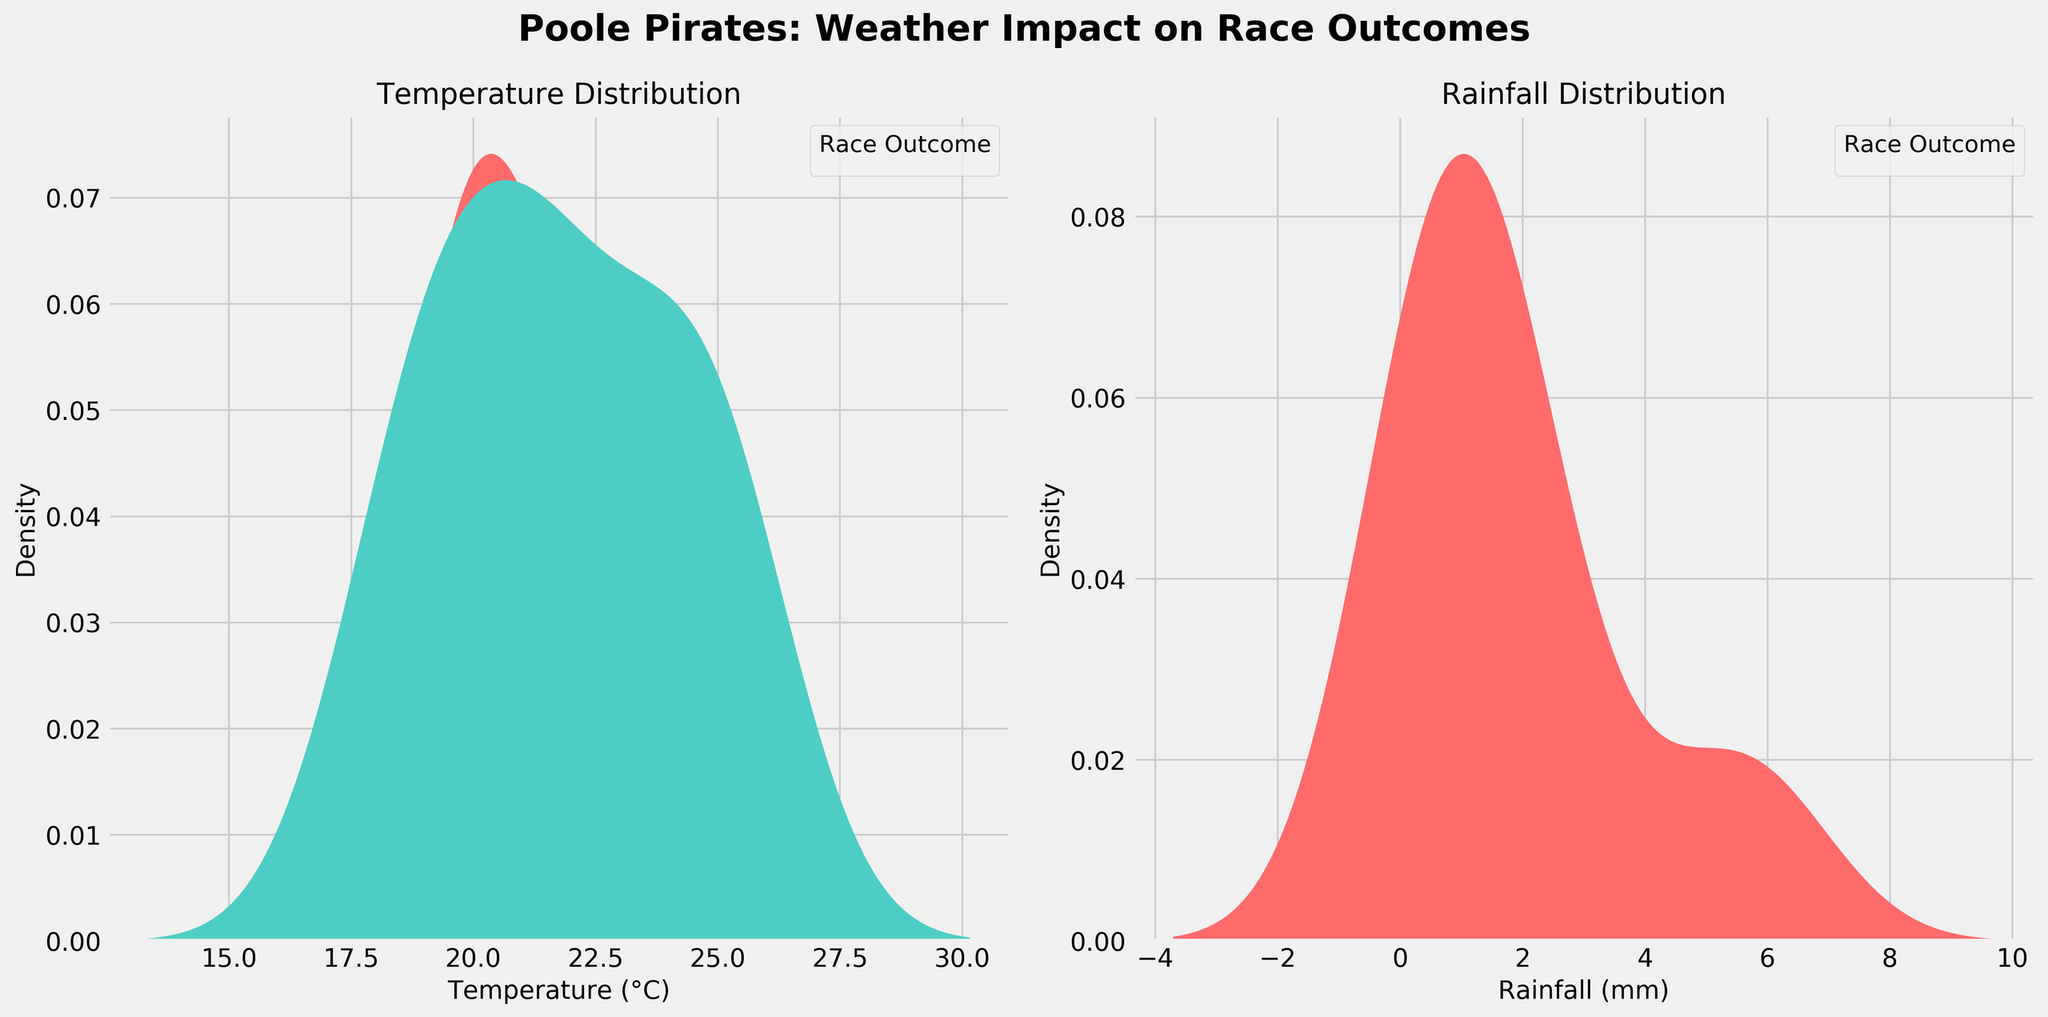What are the titles of the two subplots? The first subplot's title is "Temperature Distribution," and the second subplot's title is "Rainfall Distribution."
Answer: Temperature Distribution and Rainfall Distribution Which category has the highest density peak for temperature, Win or Lose? In the "Temperature Distribution" subplot, the "Win" category has the highest density peak. This can be seen from the shaded area under the curve, which is higher for "Win" compared to "Lose."
Answer: Win What is the general trend for race outcomes based on temperature? The "Win" curves in the "Temperature Distribution" subplot show higher density peaks at higher temperature ranges compared to the "Lose" curves, indicating a trend where higher temperatures are associated with more wins.
Answer: Higher temperatures are associated with more wins How does rainfall distribution differ for wins and losses? In the "Rainfall Distribution" subplot, wins have a higher density peak at lower rainfall values (close to 0), while losses are more spread out and have density peaks at higher rainfall values. This suggests that wins tend to occur on days with little to no rainfall, whereas losses occur more frequently at higher rainfall levels.
Answer: Wins tend to occur on days with low rainfall; losses occur more at higher rainfall Is there any overlap between the temperature distributions for wins and losses? Yes, there is some overlap between the temperature distributions for wins and losses in the "Temperature Distribution" subplot, especially in the mid-range temperatures around 20-22°C.
Answer: Yes Which category seems to be unaffected by the rainfall, Win or Lose? In the "Rainfall Distribution" subplot, the "Win" category shows a sharp peak at 0 mm of rainfall and then quickly diminishes, implying that wins are largely unaffected by rainfall as they mostly occur on dry days.
Answer: Win Which subplot, Temperature Distribution or Rainfall Distribution, shows a more evident distinction between wins and losses? The "Rainfall Distribution" subplot shows a more evident distinction because the "Win" curve is highly concentrated at 0 mm of rainfall, whereas the "Lose" curve is more spread out with peaks at higher rainfall values.
Answer: Rainfall Distribution Based on both subplots, under which weather conditions does the Poole Pirates team show the best performance? The Poole Pirates team shows the best performance (most wins) under higher temperature conditions and low (near 0) rainfall conditions as per the peaks in the "Temperature Distribution" and "Rainfall Distribution" subplots.
Answer: Higher temperatures and low rainfall How often do races with rainfall above 2 mm result in wins? In the "Rainfall Distribution" subplot, the density for the "Win" category is nearly non-existent above 2 mm of rainfall, meaning that races with rainfall above 2 mm rarely result in wins.
Answer: Rarely 